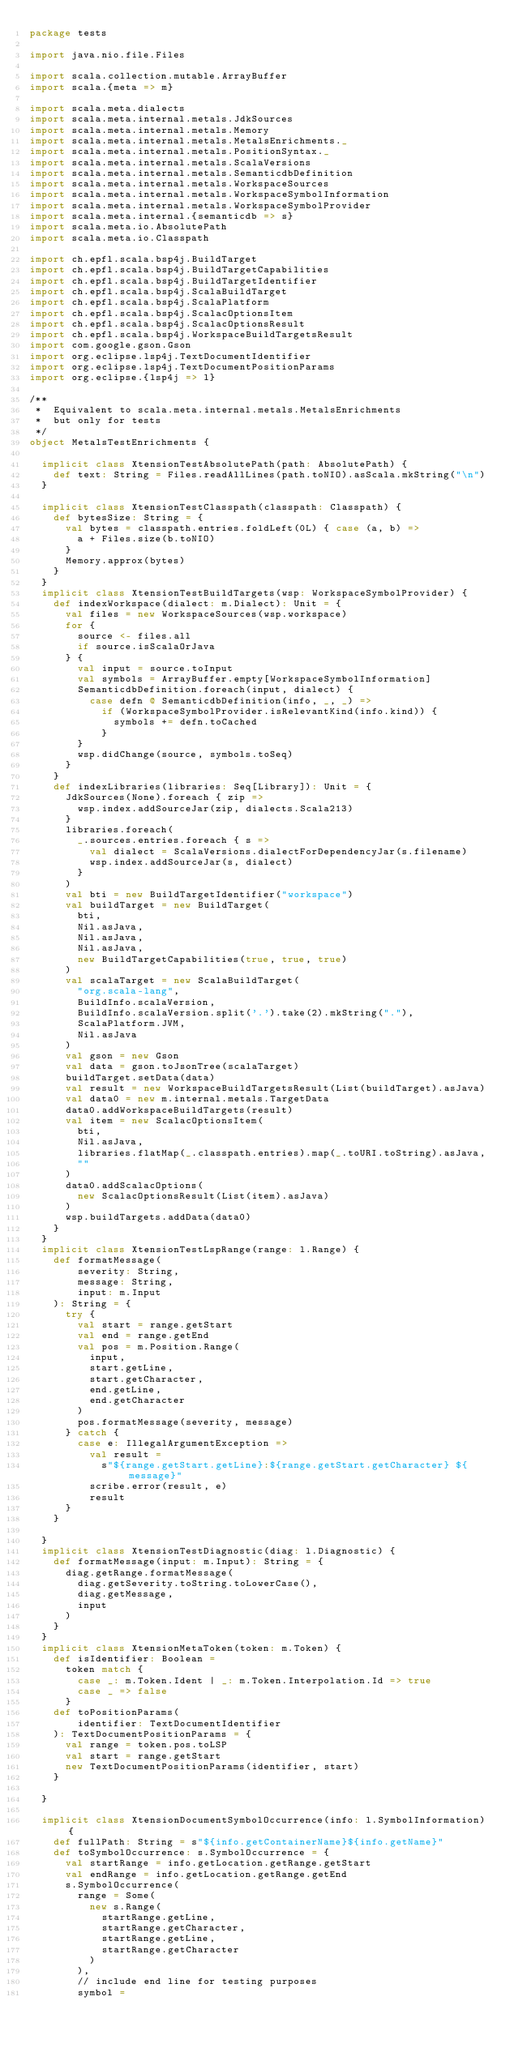Convert code to text. <code><loc_0><loc_0><loc_500><loc_500><_Scala_>package tests

import java.nio.file.Files

import scala.collection.mutable.ArrayBuffer
import scala.{meta => m}

import scala.meta.dialects
import scala.meta.internal.metals.JdkSources
import scala.meta.internal.metals.Memory
import scala.meta.internal.metals.MetalsEnrichments._
import scala.meta.internal.metals.PositionSyntax._
import scala.meta.internal.metals.ScalaVersions
import scala.meta.internal.metals.SemanticdbDefinition
import scala.meta.internal.metals.WorkspaceSources
import scala.meta.internal.metals.WorkspaceSymbolInformation
import scala.meta.internal.metals.WorkspaceSymbolProvider
import scala.meta.internal.{semanticdb => s}
import scala.meta.io.AbsolutePath
import scala.meta.io.Classpath

import ch.epfl.scala.bsp4j.BuildTarget
import ch.epfl.scala.bsp4j.BuildTargetCapabilities
import ch.epfl.scala.bsp4j.BuildTargetIdentifier
import ch.epfl.scala.bsp4j.ScalaBuildTarget
import ch.epfl.scala.bsp4j.ScalaPlatform
import ch.epfl.scala.bsp4j.ScalacOptionsItem
import ch.epfl.scala.bsp4j.ScalacOptionsResult
import ch.epfl.scala.bsp4j.WorkspaceBuildTargetsResult
import com.google.gson.Gson
import org.eclipse.lsp4j.TextDocumentIdentifier
import org.eclipse.lsp4j.TextDocumentPositionParams
import org.eclipse.{lsp4j => l}

/**
 *  Equivalent to scala.meta.internal.metals.MetalsEnrichments
 *  but only for tests
 */
object MetalsTestEnrichments {

  implicit class XtensionTestAbsolutePath(path: AbsolutePath) {
    def text: String = Files.readAllLines(path.toNIO).asScala.mkString("\n")
  }

  implicit class XtensionTestClasspath(classpath: Classpath) {
    def bytesSize: String = {
      val bytes = classpath.entries.foldLeft(0L) { case (a, b) =>
        a + Files.size(b.toNIO)
      }
      Memory.approx(bytes)
    }
  }
  implicit class XtensionTestBuildTargets(wsp: WorkspaceSymbolProvider) {
    def indexWorkspace(dialect: m.Dialect): Unit = {
      val files = new WorkspaceSources(wsp.workspace)
      for {
        source <- files.all
        if source.isScalaOrJava
      } {
        val input = source.toInput
        val symbols = ArrayBuffer.empty[WorkspaceSymbolInformation]
        SemanticdbDefinition.foreach(input, dialect) {
          case defn @ SemanticdbDefinition(info, _, _) =>
            if (WorkspaceSymbolProvider.isRelevantKind(info.kind)) {
              symbols += defn.toCached
            }
        }
        wsp.didChange(source, symbols.toSeq)
      }
    }
    def indexLibraries(libraries: Seq[Library]): Unit = {
      JdkSources(None).foreach { zip =>
        wsp.index.addSourceJar(zip, dialects.Scala213)
      }
      libraries.foreach(
        _.sources.entries.foreach { s =>
          val dialect = ScalaVersions.dialectForDependencyJar(s.filename)
          wsp.index.addSourceJar(s, dialect)
        }
      )
      val bti = new BuildTargetIdentifier("workspace")
      val buildTarget = new BuildTarget(
        bti,
        Nil.asJava,
        Nil.asJava,
        Nil.asJava,
        new BuildTargetCapabilities(true, true, true)
      )
      val scalaTarget = new ScalaBuildTarget(
        "org.scala-lang",
        BuildInfo.scalaVersion,
        BuildInfo.scalaVersion.split('.').take(2).mkString("."),
        ScalaPlatform.JVM,
        Nil.asJava
      )
      val gson = new Gson
      val data = gson.toJsonTree(scalaTarget)
      buildTarget.setData(data)
      val result = new WorkspaceBuildTargetsResult(List(buildTarget).asJava)
      val data0 = new m.internal.metals.TargetData
      data0.addWorkspaceBuildTargets(result)
      val item = new ScalacOptionsItem(
        bti,
        Nil.asJava,
        libraries.flatMap(_.classpath.entries).map(_.toURI.toString).asJava,
        ""
      )
      data0.addScalacOptions(
        new ScalacOptionsResult(List(item).asJava)
      )
      wsp.buildTargets.addData(data0)
    }
  }
  implicit class XtensionTestLspRange(range: l.Range) {
    def formatMessage(
        severity: String,
        message: String,
        input: m.Input
    ): String = {
      try {
        val start = range.getStart
        val end = range.getEnd
        val pos = m.Position.Range(
          input,
          start.getLine,
          start.getCharacter,
          end.getLine,
          end.getCharacter
        )
        pos.formatMessage(severity, message)
      } catch {
        case e: IllegalArgumentException =>
          val result =
            s"${range.getStart.getLine}:${range.getStart.getCharacter} ${message}"
          scribe.error(result, e)
          result
      }
    }

  }
  implicit class XtensionTestDiagnostic(diag: l.Diagnostic) {
    def formatMessage(input: m.Input): String = {
      diag.getRange.formatMessage(
        diag.getSeverity.toString.toLowerCase(),
        diag.getMessage,
        input
      )
    }
  }
  implicit class XtensionMetaToken(token: m.Token) {
    def isIdentifier: Boolean =
      token match {
        case _: m.Token.Ident | _: m.Token.Interpolation.Id => true
        case _ => false
      }
    def toPositionParams(
        identifier: TextDocumentIdentifier
    ): TextDocumentPositionParams = {
      val range = token.pos.toLSP
      val start = range.getStart
      new TextDocumentPositionParams(identifier, start)
    }

  }

  implicit class XtensionDocumentSymbolOccurrence(info: l.SymbolInformation) {
    def fullPath: String = s"${info.getContainerName}${info.getName}"
    def toSymbolOccurrence: s.SymbolOccurrence = {
      val startRange = info.getLocation.getRange.getStart
      val endRange = info.getLocation.getRange.getEnd
      s.SymbolOccurrence(
        range = Some(
          new s.Range(
            startRange.getLine,
            startRange.getCharacter,
            startRange.getLine,
            startRange.getCharacter
          )
        ),
        // include end line for testing purposes
        symbol =</code> 